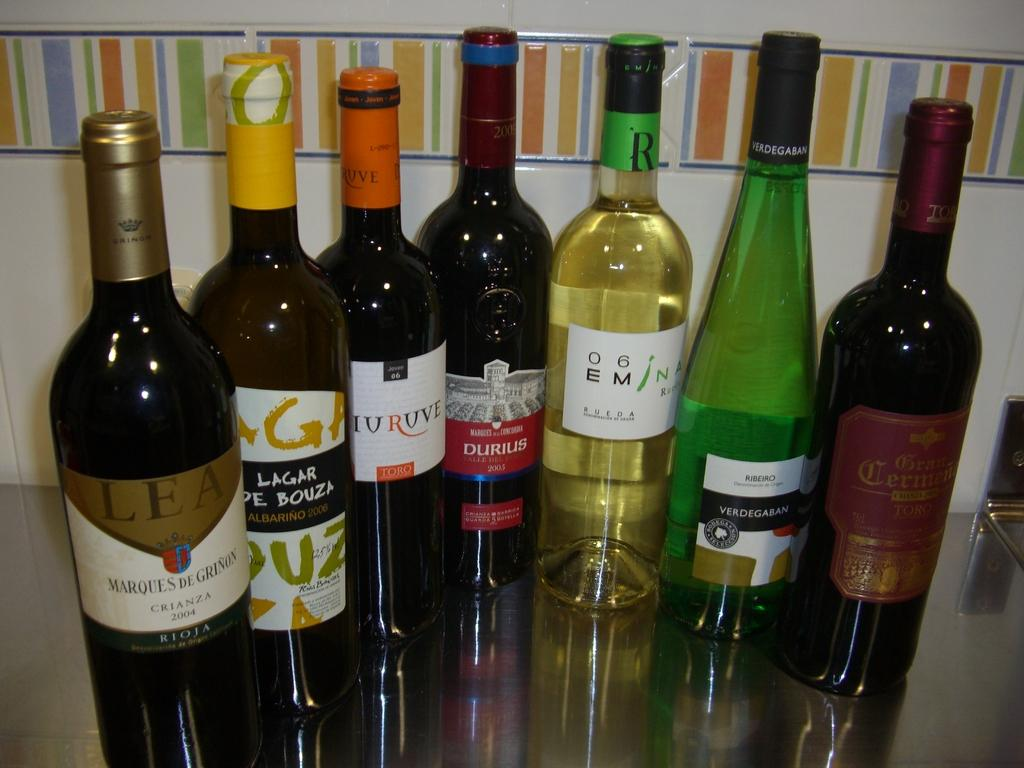<image>
Share a concise interpretation of the image provided. seven bottlesof wine such as o6em and durius 